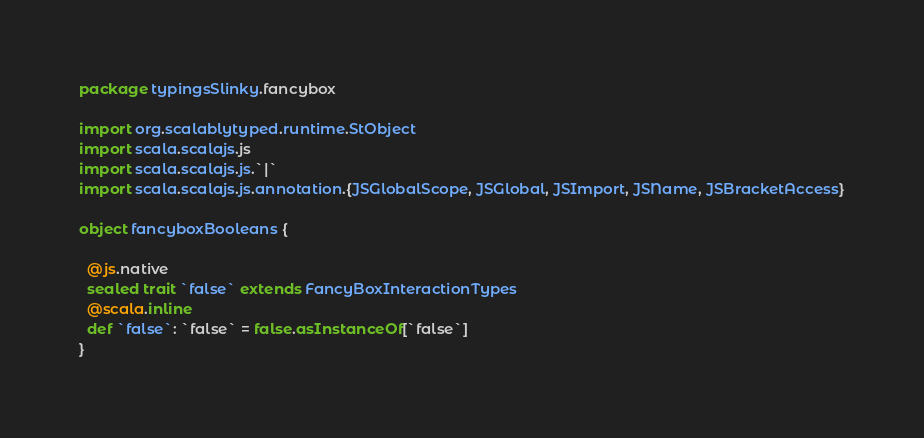<code> <loc_0><loc_0><loc_500><loc_500><_Scala_>package typingsSlinky.fancybox

import org.scalablytyped.runtime.StObject
import scala.scalajs.js
import scala.scalajs.js.`|`
import scala.scalajs.js.annotation.{JSGlobalScope, JSGlobal, JSImport, JSName, JSBracketAccess}

object fancyboxBooleans {
  
  @js.native
  sealed trait `false` extends FancyBoxInteractionTypes
  @scala.inline
  def `false`: `false` = false.asInstanceOf[`false`]
}
</code> 